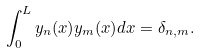Convert formula to latex. <formula><loc_0><loc_0><loc_500><loc_500>\int _ { 0 } ^ { L } y _ { n } ( x ) y _ { m } ( x ) d x = \delta _ { n , m } .</formula> 